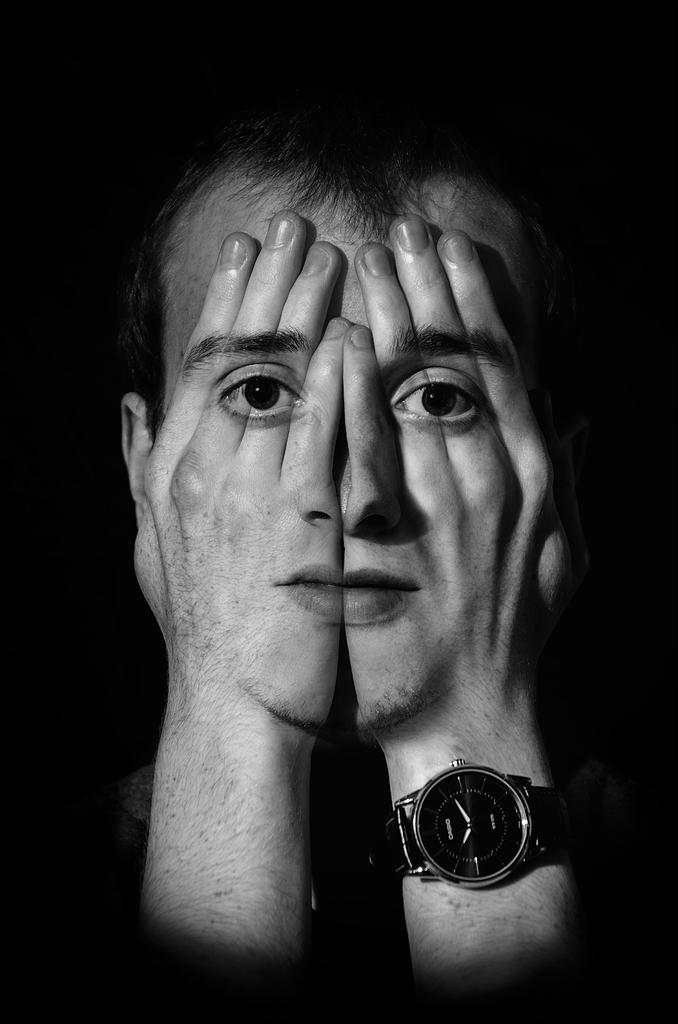What is the main subject of the image? There is a person in the image. What is the color scheme of the image? The image is black and white. How would you describe the background of the image? The background of the image is dark. What is the person in the image doing with their hands? The person is covering their face with their hands. What can be seen on the person's hands? A face is visible on the person's hands. Can you tell me how many airports are visible in the image? There are no airports present in the image. What type of approval is the person seeking in the image? There is no indication of approval or disapproval in the image; the person is simply covering their face with their hands. 